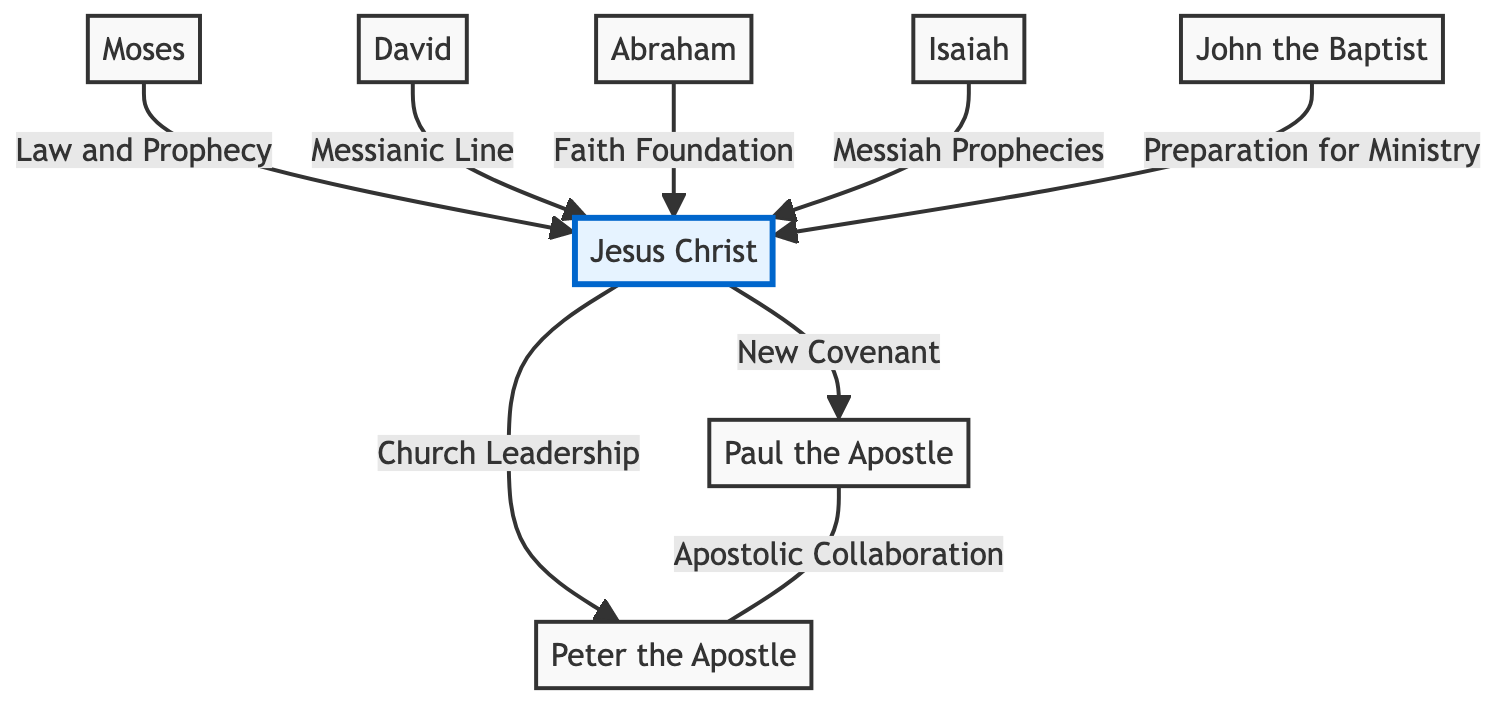What is the central figure in this diagram? The diagram highlights Jesus Christ as the central figure, as indicated by the special class designation assigned to him. This visual cue signifies that he plays a pivotal role in linking multiple other biblical figures and concepts.
Answer: Jesus Christ How many nodes are present in the diagram? The diagram contains a total of eight nodes that represent different key biblical figures, illustrating their individual significance and connections to one another.
Answer: 8 What relationship exists between Moses and Jesus Christ? The diagram specifies the relationship as "Law and Prophecy", showing that Moses’s contributions to law and prophecy have a direct significance in understanding Jesus Christ's role in Christianity.
Answer: Law and Prophecy Which figure is associated with the "Messianic Line"? The diagram indicates that David is connected to the term "Messianic Line," signifying his importance in the lineage leading to Jesus Christ. This relationship is essential to understand the fulfillment of prophecies about the Messiah.
Answer: David Who is directly connected to Peter the Apostle? The diagram shows that Paul the Apostle is directly connected to Peter the Apostle through the label "Apostolic Collaboration," indicating their partnership and shared mission in the early Christian church.
Answer: Paul the Apostle Which biblical figure lays the foundation of faith? Abraham is identified as the biblical figure providing the "Faith Foundation," establishing crucial beliefs that underpin both Jewish and Christian traditions, thus influencing modern day beliefs.
Answer: Abraham What is the relationship description between Isaiah and Jesus? The relationship between Isaiah and Jesus Christ is described as "Messiah Prophecies." This connection highlights the prophetic messages from Isaiah that are seen as foretelling Jesus' coming.
Answer: Messiah Prophecies How many edges are present in the diagram? The diagram includes seven edges that represent the various relationships among the biblical figures, illustrating the interconnectedness of their influences and teachings.
Answer: 7 What role does John the Baptist play in relation to Jesus? John the Baptist is linked to Jesus through the description "Preparation for Ministry," indicating his role in preparing the way for Jesus' teachings and baptism.
Answer: Preparation for Ministry 